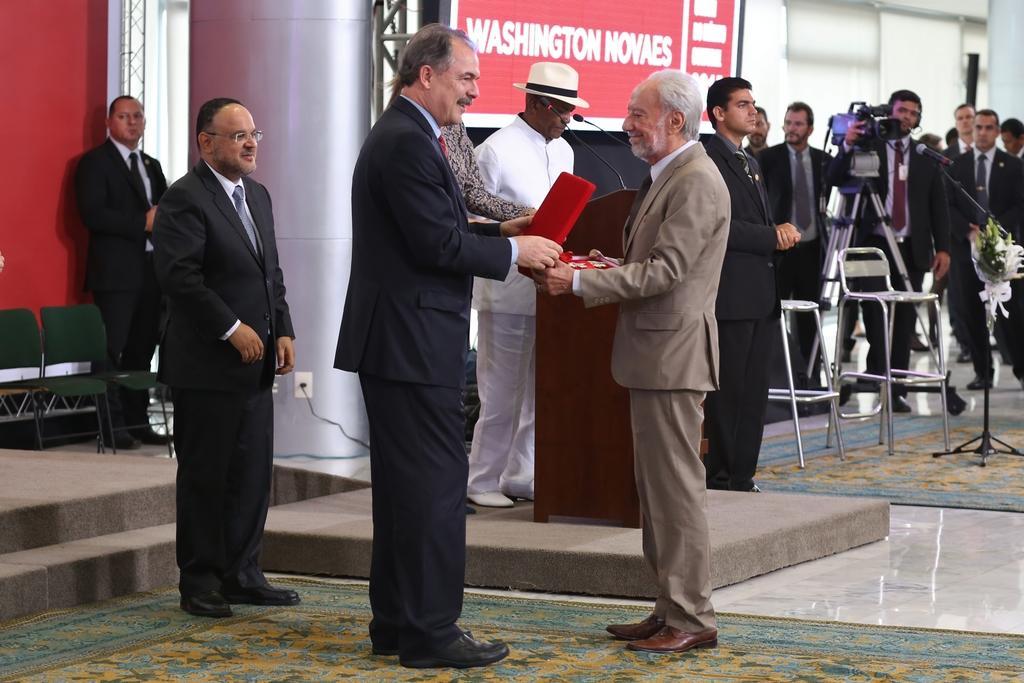Can you describe this image briefly? In this picture I can see there are some people standing here and in the backdrop I can see these two people are holding a red color object and there are some chairs and these people are holding camera and there is a screen and a banner in the backdrop. 